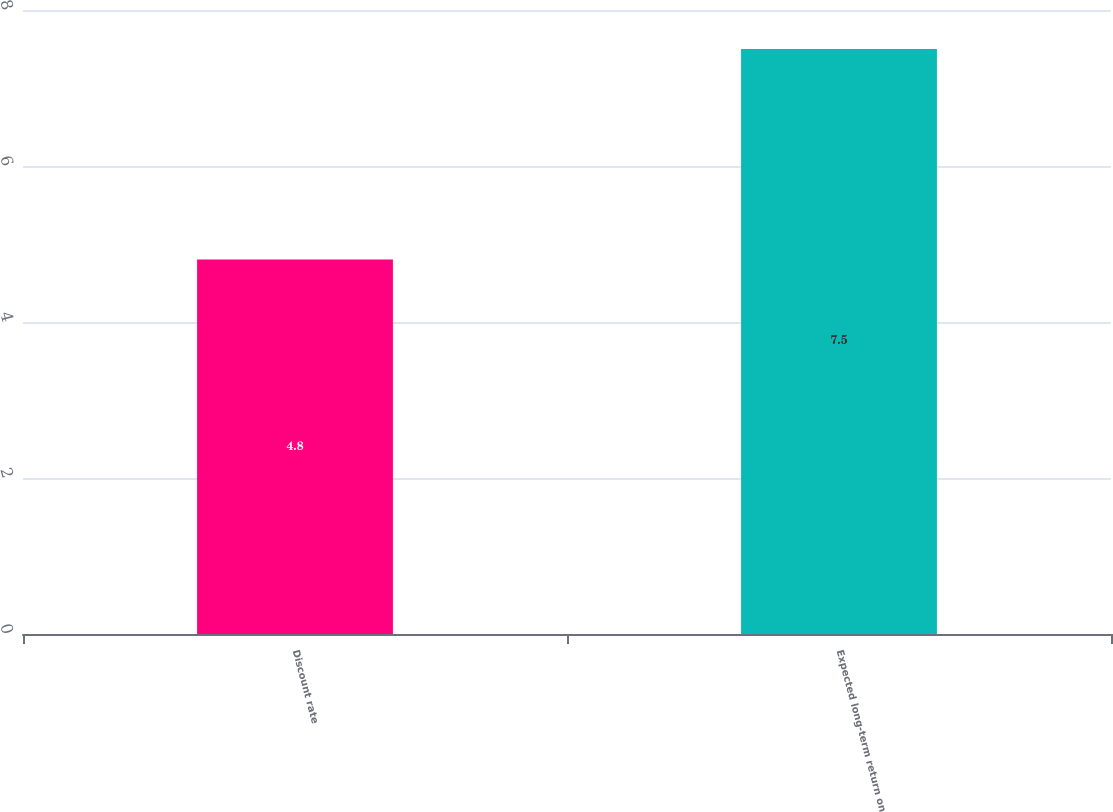<chart> <loc_0><loc_0><loc_500><loc_500><bar_chart><fcel>Discount rate<fcel>Expected long-term return on<nl><fcel>4.8<fcel>7.5<nl></chart> 